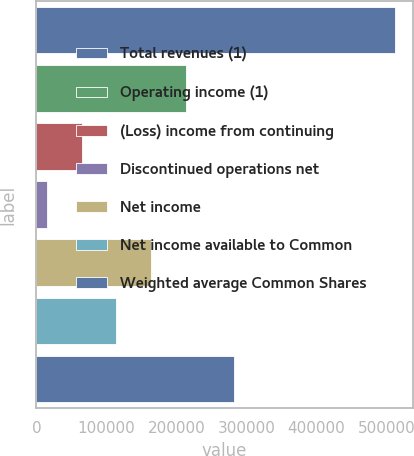<chart> <loc_0><loc_0><loc_500><loc_500><bar_chart><fcel>Total revenues (1)<fcel>Operating income (1)<fcel>(Loss) income from continuing<fcel>Discontinued operations net<fcel>Net income<fcel>Net income available to Common<fcel>Weighted average Common Shares<nl><fcel>511772<fcel>213646<fcel>64583.6<fcel>14896<fcel>163959<fcel>114271<fcel>282717<nl></chart> 